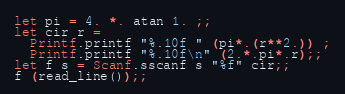<code> <loc_0><loc_0><loc_500><loc_500><_OCaml_>let pi = 4. *. atan 1. ;;
let cir r =
  Printf.printf "%.10f " (pi*.(r**2.)) ;
  Printf.printf "%.10f\n" (2.*.pi*.r);;
let f s = Scanf.sscanf s "%f" cir;;
f (read_line());;
</code> 